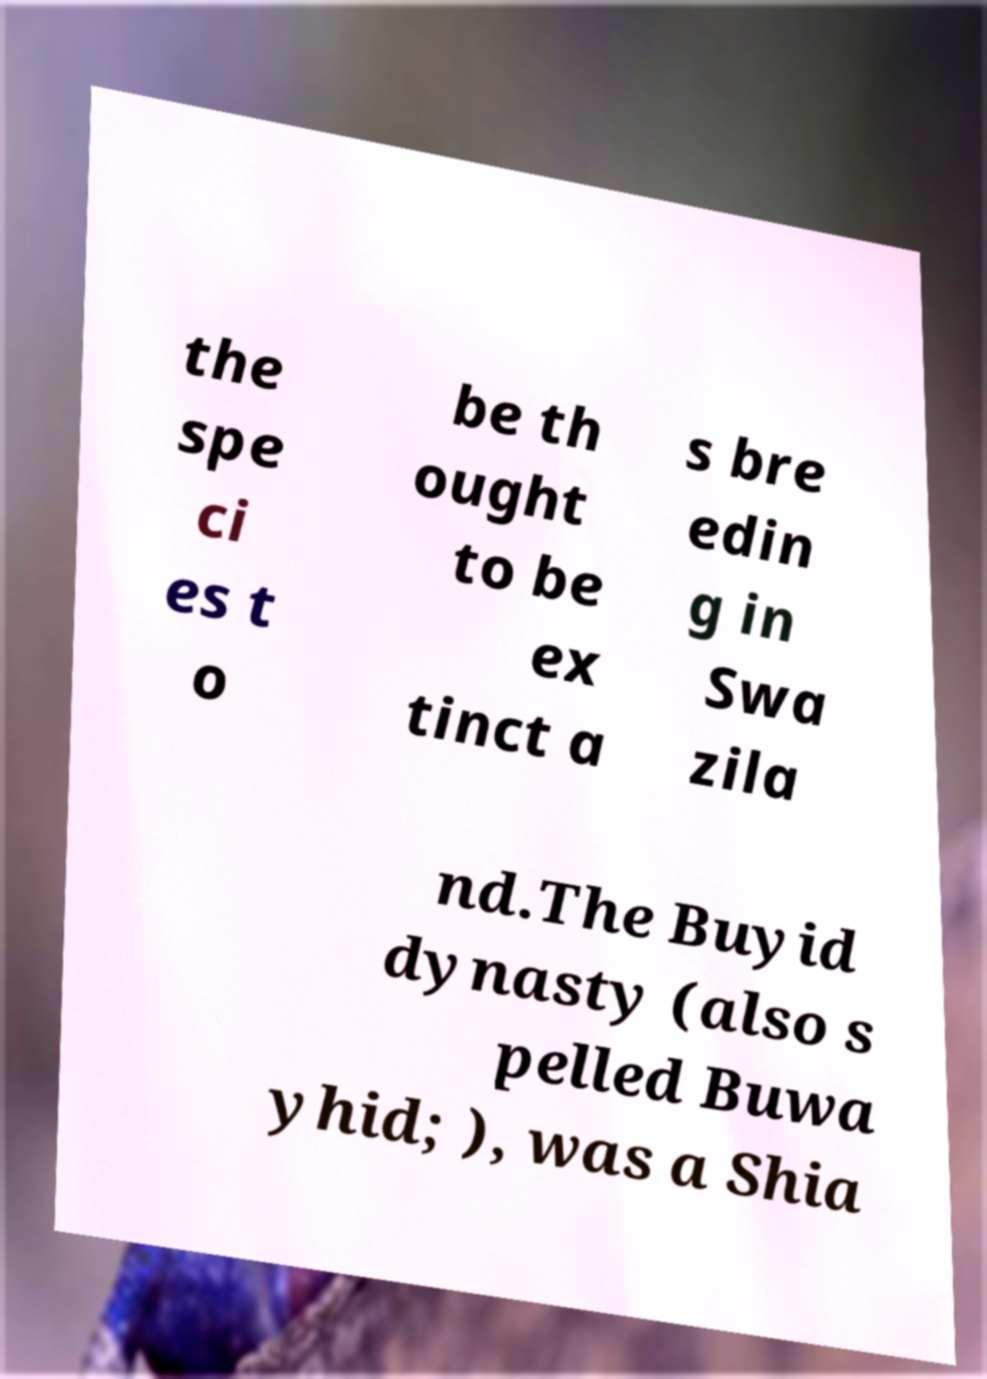Could you assist in decoding the text presented in this image and type it out clearly? the spe ci es t o be th ought to be ex tinct a s bre edin g in Swa zila nd.The Buyid dynasty (also s pelled Buwa yhid; ), was a Shia 